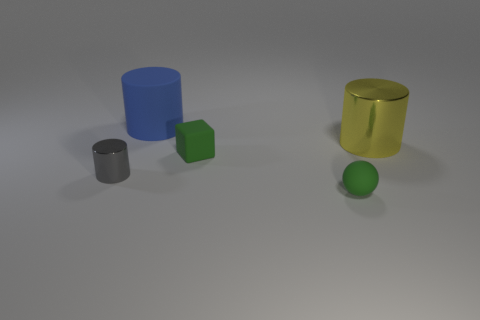Add 2 big metallic cylinders. How many objects exist? 7 Subtract all cylinders. How many objects are left? 2 Add 2 blue things. How many blue things exist? 3 Subtract 0 red cylinders. How many objects are left? 5 Subtract all large blue rubber cylinders. Subtract all small gray metallic objects. How many objects are left? 3 Add 2 large metallic cylinders. How many large metallic cylinders are left? 3 